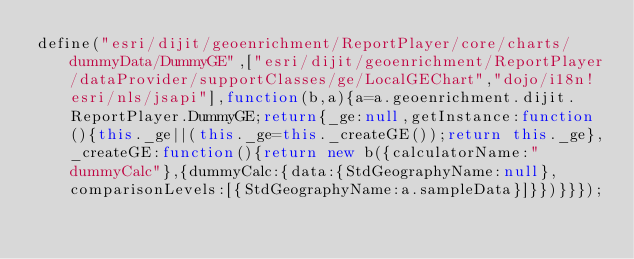Convert code to text. <code><loc_0><loc_0><loc_500><loc_500><_JavaScript_>define("esri/dijit/geoenrichment/ReportPlayer/core/charts/dummyData/DummyGE",["esri/dijit/geoenrichment/ReportPlayer/dataProvider/supportClasses/ge/LocalGEChart","dojo/i18n!esri/nls/jsapi"],function(b,a){a=a.geoenrichment.dijit.ReportPlayer.DummyGE;return{_ge:null,getInstance:function(){this._ge||(this._ge=this._createGE());return this._ge},_createGE:function(){return new b({calculatorName:"dummyCalc"},{dummyCalc:{data:{StdGeographyName:null},comparisonLevels:[{StdGeographyName:a.sampleData}]}})}}});</code> 